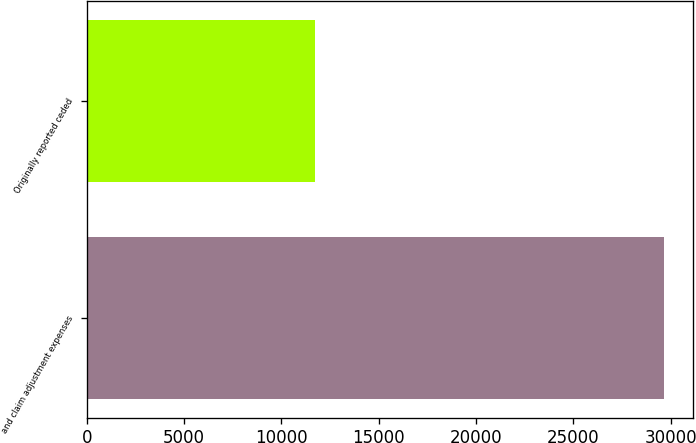<chart> <loc_0><loc_0><loc_500><loc_500><bar_chart><fcel>and claim adjustment expenses<fcel>Originally reported ceded<nl><fcel>29649<fcel>11703<nl></chart> 